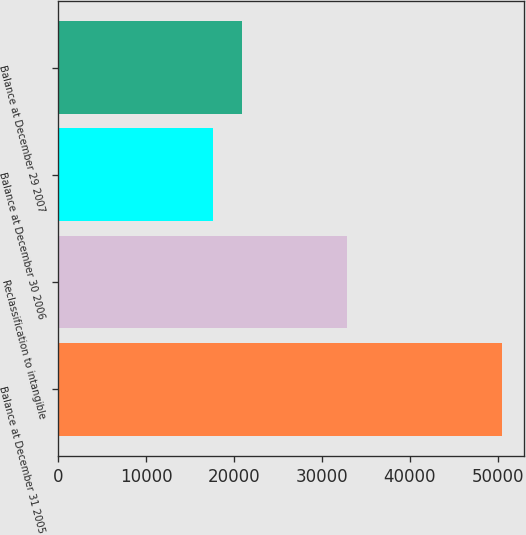Convert chart. <chart><loc_0><loc_0><loc_500><loc_500><bar_chart><fcel>Balance at December 31 2005<fcel>Reclassification to intangible<fcel>Balance at December 30 2006<fcel>Balance at December 29 2007<nl><fcel>50440<fcel>32815<fcel>17625<fcel>20906.5<nl></chart> 